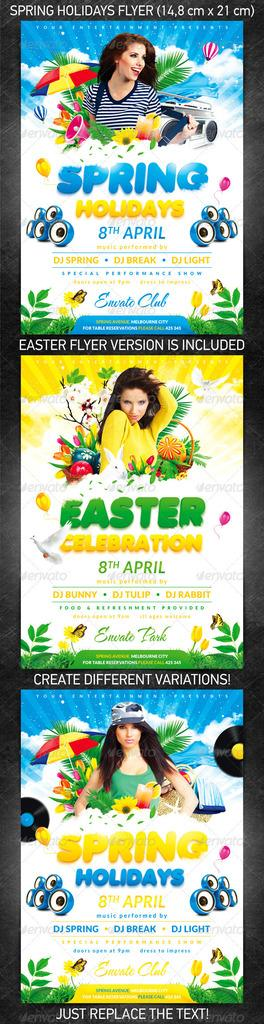Provide a one-sentence caption for the provided image. Three colorful flyer examples for an Easter celebration. 